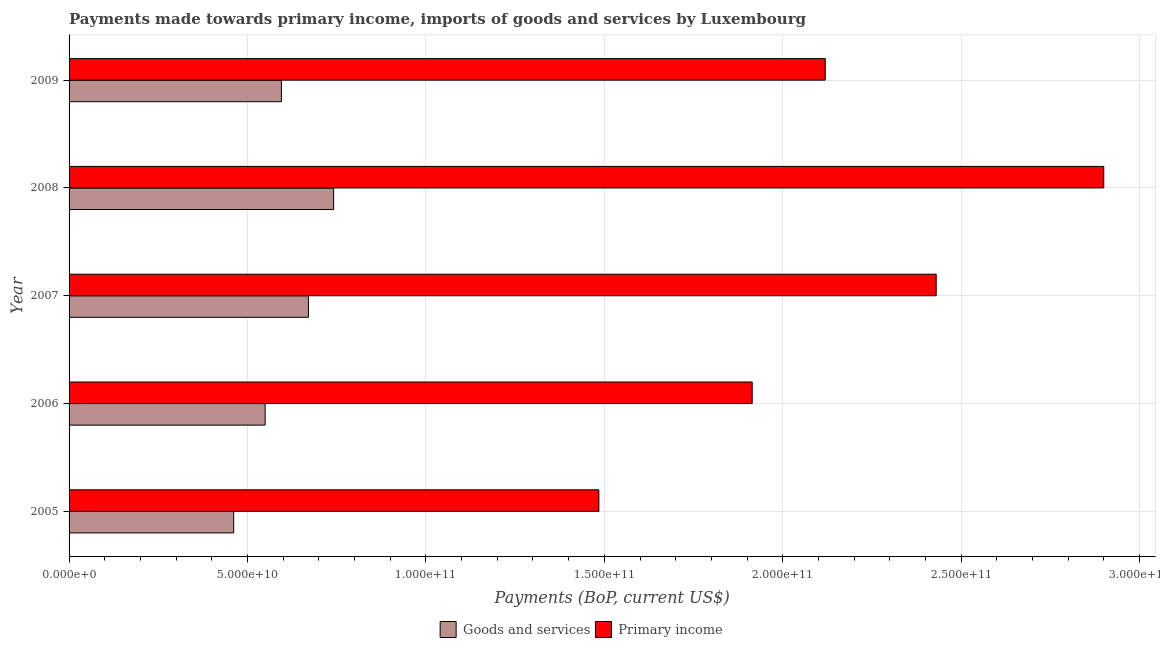How many groups of bars are there?
Provide a succinct answer. 5. How many bars are there on the 1st tick from the top?
Provide a short and direct response. 2. How many bars are there on the 3rd tick from the bottom?
Your answer should be very brief. 2. In how many cases, is the number of bars for a given year not equal to the number of legend labels?
Your answer should be compact. 0. What is the payments made towards goods and services in 2007?
Make the answer very short. 6.71e+1. Across all years, what is the maximum payments made towards primary income?
Make the answer very short. 2.90e+11. Across all years, what is the minimum payments made towards goods and services?
Ensure brevity in your answer.  4.61e+1. What is the total payments made towards primary income in the graph?
Keep it short and to the point. 1.08e+12. What is the difference between the payments made towards goods and services in 2007 and that in 2009?
Ensure brevity in your answer.  7.57e+09. What is the difference between the payments made towards primary income in 2005 and the payments made towards goods and services in 2008?
Ensure brevity in your answer.  7.43e+1. What is the average payments made towards primary income per year?
Keep it short and to the point. 2.17e+11. In the year 2007, what is the difference between the payments made towards goods and services and payments made towards primary income?
Your response must be concise. -1.76e+11. In how many years, is the payments made towards goods and services greater than 10000000000 US$?
Your answer should be very brief. 5. What is the ratio of the payments made towards goods and services in 2008 to that in 2009?
Offer a very short reply. 1.25. Is the payments made towards primary income in 2005 less than that in 2007?
Keep it short and to the point. Yes. Is the difference between the payments made towards primary income in 2008 and 2009 greater than the difference between the payments made towards goods and services in 2008 and 2009?
Your answer should be very brief. Yes. What is the difference between the highest and the second highest payments made towards goods and services?
Make the answer very short. 7.06e+09. What is the difference between the highest and the lowest payments made towards goods and services?
Keep it short and to the point. 2.80e+1. In how many years, is the payments made towards goods and services greater than the average payments made towards goods and services taken over all years?
Offer a very short reply. 2. Is the sum of the payments made towards goods and services in 2006 and 2009 greater than the maximum payments made towards primary income across all years?
Ensure brevity in your answer.  No. What does the 1st bar from the top in 2006 represents?
Offer a terse response. Primary income. What does the 2nd bar from the bottom in 2009 represents?
Offer a very short reply. Primary income. How many years are there in the graph?
Your answer should be compact. 5. Where does the legend appear in the graph?
Offer a terse response. Bottom center. How are the legend labels stacked?
Offer a terse response. Horizontal. What is the title of the graph?
Provide a succinct answer. Payments made towards primary income, imports of goods and services by Luxembourg. Does "GDP" appear as one of the legend labels in the graph?
Your response must be concise. No. What is the label or title of the X-axis?
Give a very brief answer. Payments (BoP, current US$). What is the label or title of the Y-axis?
Your answer should be compact. Year. What is the Payments (BoP, current US$) of Goods and services in 2005?
Your answer should be compact. 4.61e+1. What is the Payments (BoP, current US$) of Primary income in 2005?
Your response must be concise. 1.48e+11. What is the Payments (BoP, current US$) in Goods and services in 2006?
Your answer should be very brief. 5.49e+1. What is the Payments (BoP, current US$) in Primary income in 2006?
Your response must be concise. 1.91e+11. What is the Payments (BoP, current US$) of Goods and services in 2007?
Make the answer very short. 6.71e+1. What is the Payments (BoP, current US$) in Primary income in 2007?
Give a very brief answer. 2.43e+11. What is the Payments (BoP, current US$) in Goods and services in 2008?
Offer a terse response. 7.41e+1. What is the Payments (BoP, current US$) of Primary income in 2008?
Your response must be concise. 2.90e+11. What is the Payments (BoP, current US$) of Goods and services in 2009?
Provide a succinct answer. 5.95e+1. What is the Payments (BoP, current US$) of Primary income in 2009?
Your answer should be very brief. 2.12e+11. Across all years, what is the maximum Payments (BoP, current US$) of Goods and services?
Provide a short and direct response. 7.41e+1. Across all years, what is the maximum Payments (BoP, current US$) in Primary income?
Give a very brief answer. 2.90e+11. Across all years, what is the minimum Payments (BoP, current US$) in Goods and services?
Offer a terse response. 4.61e+1. Across all years, what is the minimum Payments (BoP, current US$) in Primary income?
Your answer should be very brief. 1.48e+11. What is the total Payments (BoP, current US$) in Goods and services in the graph?
Ensure brevity in your answer.  3.02e+11. What is the total Payments (BoP, current US$) of Primary income in the graph?
Make the answer very short. 1.08e+12. What is the difference between the Payments (BoP, current US$) in Goods and services in 2005 and that in 2006?
Your answer should be very brief. -8.82e+09. What is the difference between the Payments (BoP, current US$) of Primary income in 2005 and that in 2006?
Your answer should be compact. -4.30e+1. What is the difference between the Payments (BoP, current US$) in Goods and services in 2005 and that in 2007?
Provide a succinct answer. -2.09e+1. What is the difference between the Payments (BoP, current US$) of Primary income in 2005 and that in 2007?
Make the answer very short. -9.45e+1. What is the difference between the Payments (BoP, current US$) in Goods and services in 2005 and that in 2008?
Make the answer very short. -2.80e+1. What is the difference between the Payments (BoP, current US$) of Primary income in 2005 and that in 2008?
Provide a short and direct response. -1.41e+11. What is the difference between the Payments (BoP, current US$) in Goods and services in 2005 and that in 2009?
Your answer should be very brief. -1.34e+1. What is the difference between the Payments (BoP, current US$) in Primary income in 2005 and that in 2009?
Ensure brevity in your answer.  -6.34e+1. What is the difference between the Payments (BoP, current US$) of Goods and services in 2006 and that in 2007?
Keep it short and to the point. -1.21e+1. What is the difference between the Payments (BoP, current US$) of Primary income in 2006 and that in 2007?
Keep it short and to the point. -5.16e+1. What is the difference between the Payments (BoP, current US$) of Goods and services in 2006 and that in 2008?
Make the answer very short. -1.92e+1. What is the difference between the Payments (BoP, current US$) of Primary income in 2006 and that in 2008?
Your response must be concise. -9.85e+1. What is the difference between the Payments (BoP, current US$) in Goods and services in 2006 and that in 2009?
Your response must be concise. -4.56e+09. What is the difference between the Payments (BoP, current US$) of Primary income in 2006 and that in 2009?
Your response must be concise. -2.05e+1. What is the difference between the Payments (BoP, current US$) of Goods and services in 2007 and that in 2008?
Your answer should be very brief. -7.06e+09. What is the difference between the Payments (BoP, current US$) of Primary income in 2007 and that in 2008?
Your answer should be very brief. -4.70e+1. What is the difference between the Payments (BoP, current US$) in Goods and services in 2007 and that in 2009?
Your response must be concise. 7.57e+09. What is the difference between the Payments (BoP, current US$) in Primary income in 2007 and that in 2009?
Offer a terse response. 3.11e+1. What is the difference between the Payments (BoP, current US$) in Goods and services in 2008 and that in 2009?
Give a very brief answer. 1.46e+1. What is the difference between the Payments (BoP, current US$) of Primary income in 2008 and that in 2009?
Ensure brevity in your answer.  7.80e+1. What is the difference between the Payments (BoP, current US$) in Goods and services in 2005 and the Payments (BoP, current US$) in Primary income in 2006?
Give a very brief answer. -1.45e+11. What is the difference between the Payments (BoP, current US$) in Goods and services in 2005 and the Payments (BoP, current US$) in Primary income in 2007?
Your answer should be very brief. -1.97e+11. What is the difference between the Payments (BoP, current US$) in Goods and services in 2005 and the Payments (BoP, current US$) in Primary income in 2008?
Offer a terse response. -2.44e+11. What is the difference between the Payments (BoP, current US$) in Goods and services in 2005 and the Payments (BoP, current US$) in Primary income in 2009?
Ensure brevity in your answer.  -1.66e+11. What is the difference between the Payments (BoP, current US$) in Goods and services in 2006 and the Payments (BoP, current US$) in Primary income in 2007?
Give a very brief answer. -1.88e+11. What is the difference between the Payments (BoP, current US$) of Goods and services in 2006 and the Payments (BoP, current US$) of Primary income in 2008?
Offer a very short reply. -2.35e+11. What is the difference between the Payments (BoP, current US$) of Goods and services in 2006 and the Payments (BoP, current US$) of Primary income in 2009?
Your answer should be very brief. -1.57e+11. What is the difference between the Payments (BoP, current US$) of Goods and services in 2007 and the Payments (BoP, current US$) of Primary income in 2008?
Make the answer very short. -2.23e+11. What is the difference between the Payments (BoP, current US$) of Goods and services in 2007 and the Payments (BoP, current US$) of Primary income in 2009?
Provide a short and direct response. -1.45e+11. What is the difference between the Payments (BoP, current US$) of Goods and services in 2008 and the Payments (BoP, current US$) of Primary income in 2009?
Give a very brief answer. -1.38e+11. What is the average Payments (BoP, current US$) in Goods and services per year?
Keep it short and to the point. 6.04e+1. What is the average Payments (BoP, current US$) in Primary income per year?
Offer a very short reply. 2.17e+11. In the year 2005, what is the difference between the Payments (BoP, current US$) in Goods and services and Payments (BoP, current US$) in Primary income?
Offer a terse response. -1.02e+11. In the year 2006, what is the difference between the Payments (BoP, current US$) in Goods and services and Payments (BoP, current US$) in Primary income?
Keep it short and to the point. -1.36e+11. In the year 2007, what is the difference between the Payments (BoP, current US$) of Goods and services and Payments (BoP, current US$) of Primary income?
Keep it short and to the point. -1.76e+11. In the year 2008, what is the difference between the Payments (BoP, current US$) of Goods and services and Payments (BoP, current US$) of Primary income?
Offer a terse response. -2.16e+11. In the year 2009, what is the difference between the Payments (BoP, current US$) of Goods and services and Payments (BoP, current US$) of Primary income?
Keep it short and to the point. -1.52e+11. What is the ratio of the Payments (BoP, current US$) in Goods and services in 2005 to that in 2006?
Provide a short and direct response. 0.84. What is the ratio of the Payments (BoP, current US$) in Primary income in 2005 to that in 2006?
Keep it short and to the point. 0.78. What is the ratio of the Payments (BoP, current US$) in Goods and services in 2005 to that in 2007?
Your response must be concise. 0.69. What is the ratio of the Payments (BoP, current US$) in Primary income in 2005 to that in 2007?
Provide a succinct answer. 0.61. What is the ratio of the Payments (BoP, current US$) of Goods and services in 2005 to that in 2008?
Your response must be concise. 0.62. What is the ratio of the Payments (BoP, current US$) in Primary income in 2005 to that in 2008?
Offer a terse response. 0.51. What is the ratio of the Payments (BoP, current US$) in Goods and services in 2005 to that in 2009?
Offer a terse response. 0.78. What is the ratio of the Payments (BoP, current US$) of Primary income in 2005 to that in 2009?
Make the answer very short. 0.7. What is the ratio of the Payments (BoP, current US$) of Goods and services in 2006 to that in 2007?
Make the answer very short. 0.82. What is the ratio of the Payments (BoP, current US$) in Primary income in 2006 to that in 2007?
Make the answer very short. 0.79. What is the ratio of the Payments (BoP, current US$) of Goods and services in 2006 to that in 2008?
Ensure brevity in your answer.  0.74. What is the ratio of the Payments (BoP, current US$) in Primary income in 2006 to that in 2008?
Provide a short and direct response. 0.66. What is the ratio of the Payments (BoP, current US$) in Goods and services in 2006 to that in 2009?
Provide a short and direct response. 0.92. What is the ratio of the Payments (BoP, current US$) of Primary income in 2006 to that in 2009?
Ensure brevity in your answer.  0.9. What is the ratio of the Payments (BoP, current US$) of Goods and services in 2007 to that in 2008?
Offer a very short reply. 0.9. What is the ratio of the Payments (BoP, current US$) of Primary income in 2007 to that in 2008?
Offer a very short reply. 0.84. What is the ratio of the Payments (BoP, current US$) in Goods and services in 2007 to that in 2009?
Your answer should be very brief. 1.13. What is the ratio of the Payments (BoP, current US$) of Primary income in 2007 to that in 2009?
Your response must be concise. 1.15. What is the ratio of the Payments (BoP, current US$) in Goods and services in 2008 to that in 2009?
Offer a terse response. 1.25. What is the ratio of the Payments (BoP, current US$) in Primary income in 2008 to that in 2009?
Your answer should be compact. 1.37. What is the difference between the highest and the second highest Payments (BoP, current US$) in Goods and services?
Provide a short and direct response. 7.06e+09. What is the difference between the highest and the second highest Payments (BoP, current US$) in Primary income?
Ensure brevity in your answer.  4.70e+1. What is the difference between the highest and the lowest Payments (BoP, current US$) in Goods and services?
Your answer should be very brief. 2.80e+1. What is the difference between the highest and the lowest Payments (BoP, current US$) in Primary income?
Provide a succinct answer. 1.41e+11. 